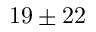<formula> <loc_0><loc_0><loc_500><loc_500>1 9 \pm 2 2</formula> 